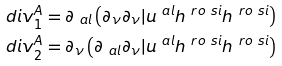Convert formula to latex. <formula><loc_0><loc_0><loc_500><loc_500>d i v ^ { A } _ { 1 } & = \partial _ { \ a l } \left ( \partial _ { \nu } \partial _ { \nu } | u ^ { \ a l } h ^ { \ r o \ s i } h ^ { \ r o \ s i } \right ) \\ d i v ^ { A } _ { 2 } & = \partial _ { \nu } \left ( \partial _ { \ a l } \partial _ { \nu } | u ^ { \ a l } h ^ { \ r o \ s i } h ^ { \ r o \ s i } \right ) \\</formula> 